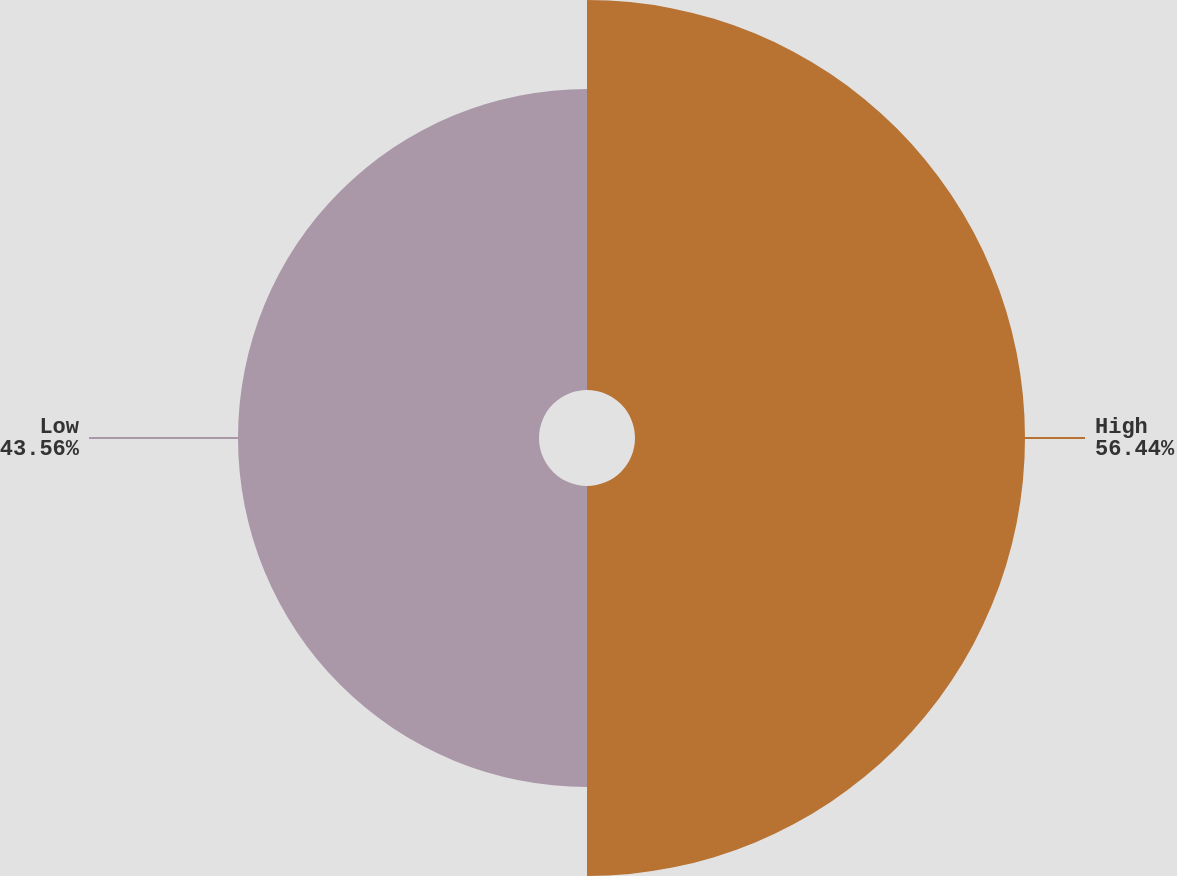Convert chart. <chart><loc_0><loc_0><loc_500><loc_500><pie_chart><fcel>High<fcel>Low<nl><fcel>56.44%<fcel>43.56%<nl></chart> 